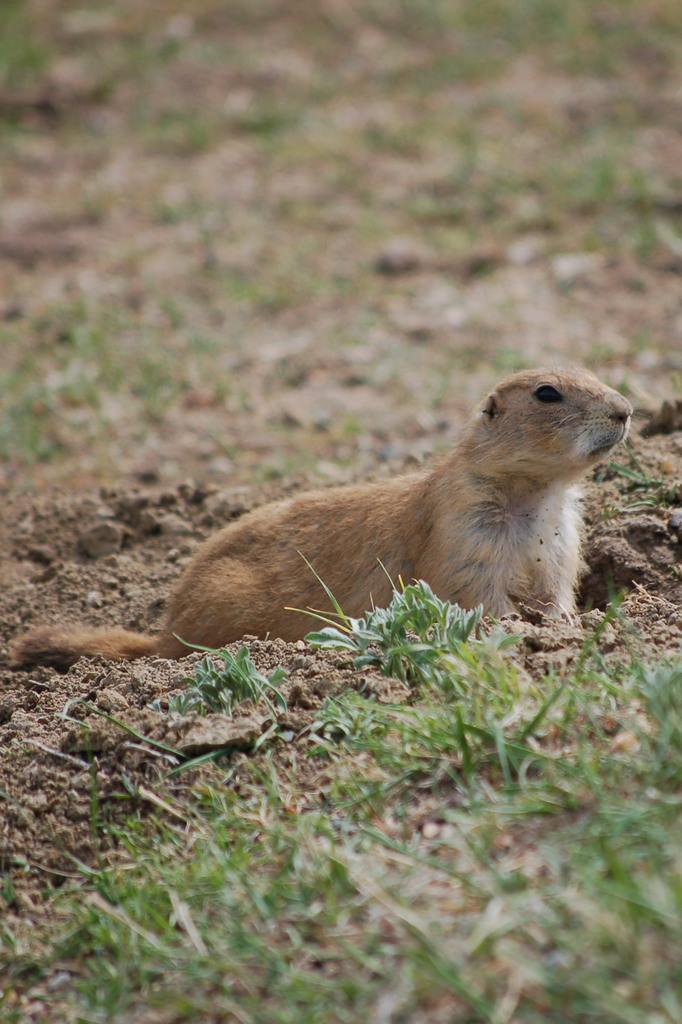In one or two sentences, can you explain what this image depicts? In the center of the image there is a animal. At the bottom of the image there is grass. 